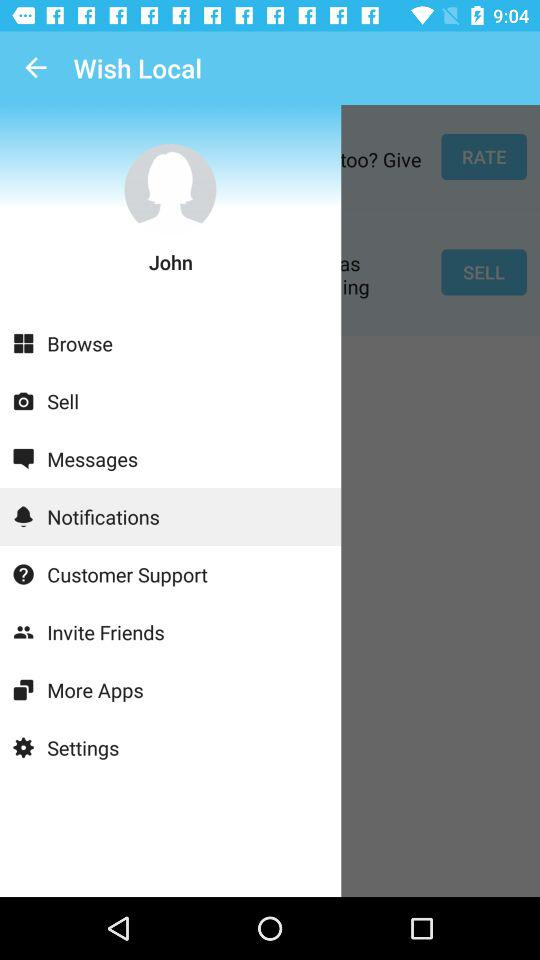What is the name of the application? The name of the application is "Wish Local". 